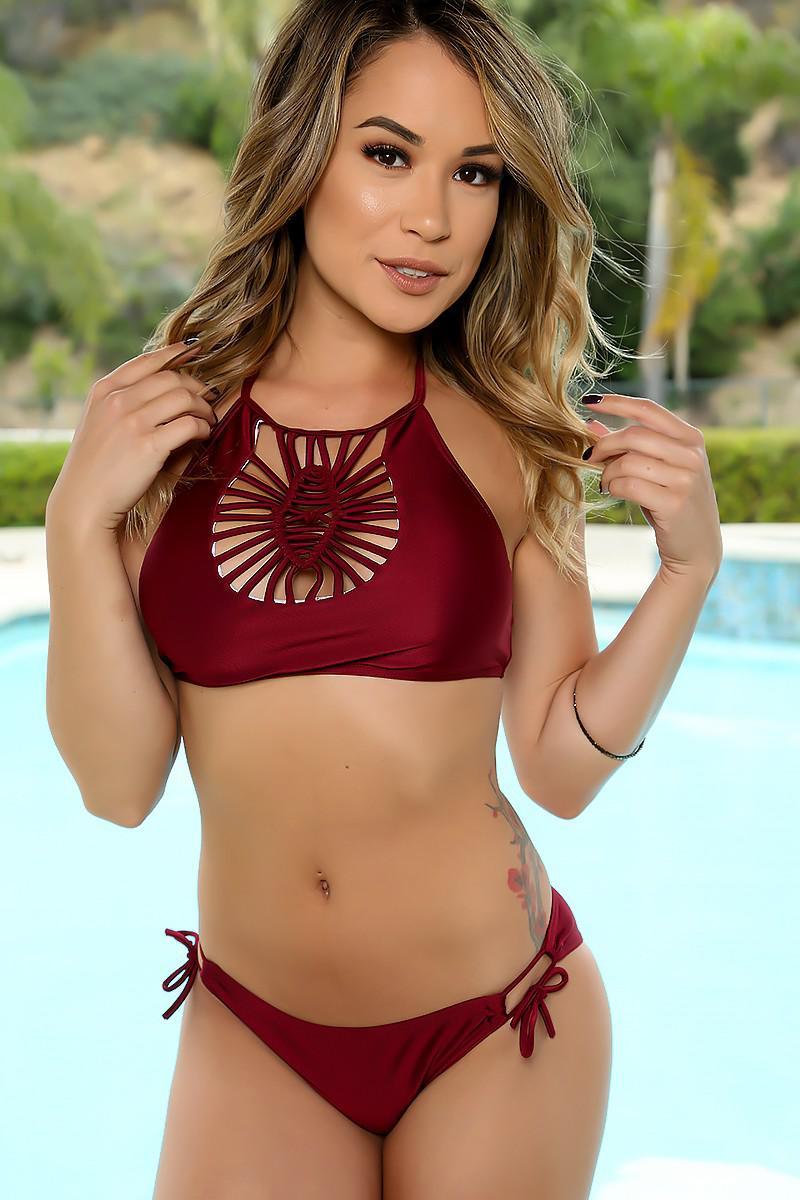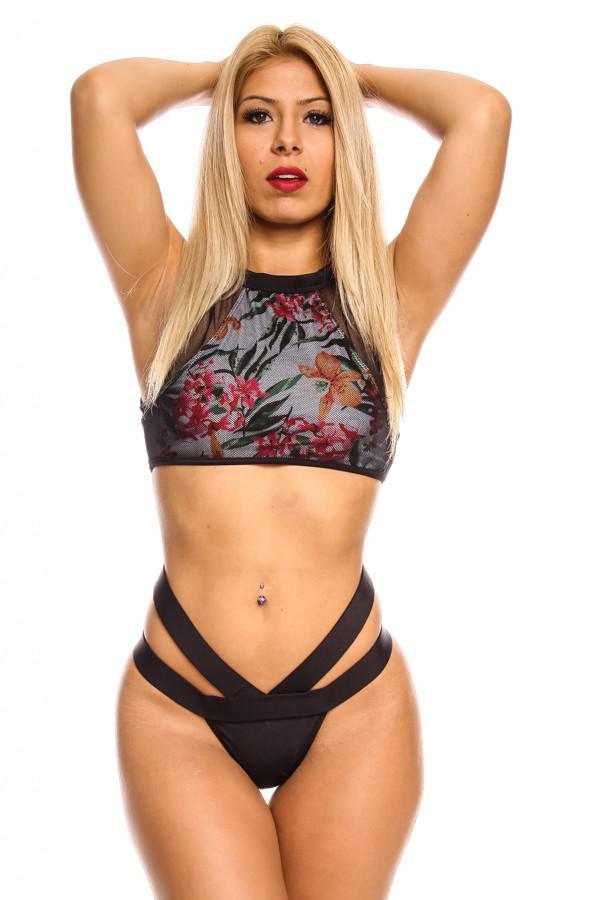The first image is the image on the left, the second image is the image on the right. Evaluate the accuracy of this statement regarding the images: "At least one image shows a model wearing a high-waisted bikini bottom that just reaches the navel.". Is it true? Answer yes or no. No. The first image is the image on the left, the second image is the image on the right. For the images displayed, is the sentence "There is one red bikini" factually correct? Answer yes or no. Yes. 